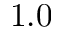Convert formula to latex. <formula><loc_0><loc_0><loc_500><loc_500>1 . 0</formula> 